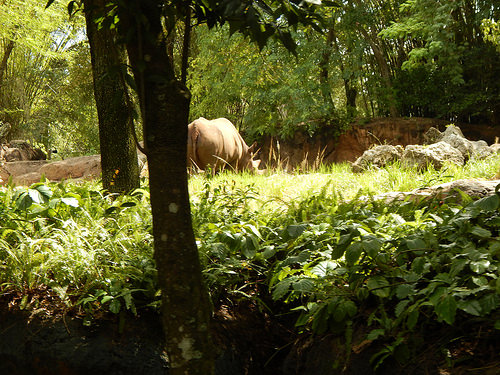<image>
Is the rhinoceros on the ground? Yes. Looking at the image, I can see the rhinoceros is positioned on top of the ground, with the ground providing support. 